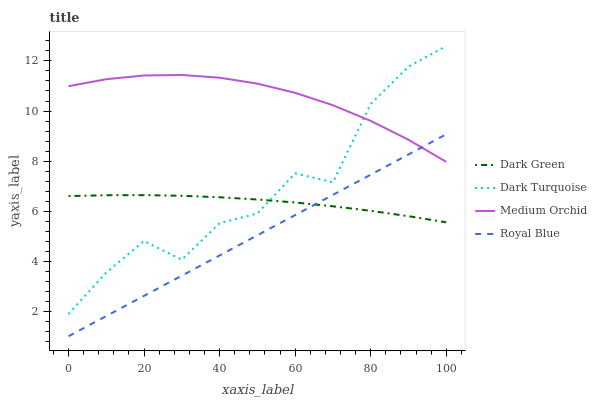Does Medium Orchid have the minimum area under the curve?
Answer yes or no. No. Does Royal Blue have the maximum area under the curve?
Answer yes or no. No. Is Medium Orchid the smoothest?
Answer yes or no. No. Is Medium Orchid the roughest?
Answer yes or no. No. Does Medium Orchid have the lowest value?
Answer yes or no. No. Does Medium Orchid have the highest value?
Answer yes or no. No. Is Royal Blue less than Dark Turquoise?
Answer yes or no. Yes. Is Dark Turquoise greater than Royal Blue?
Answer yes or no. Yes. Does Royal Blue intersect Dark Turquoise?
Answer yes or no. No. 